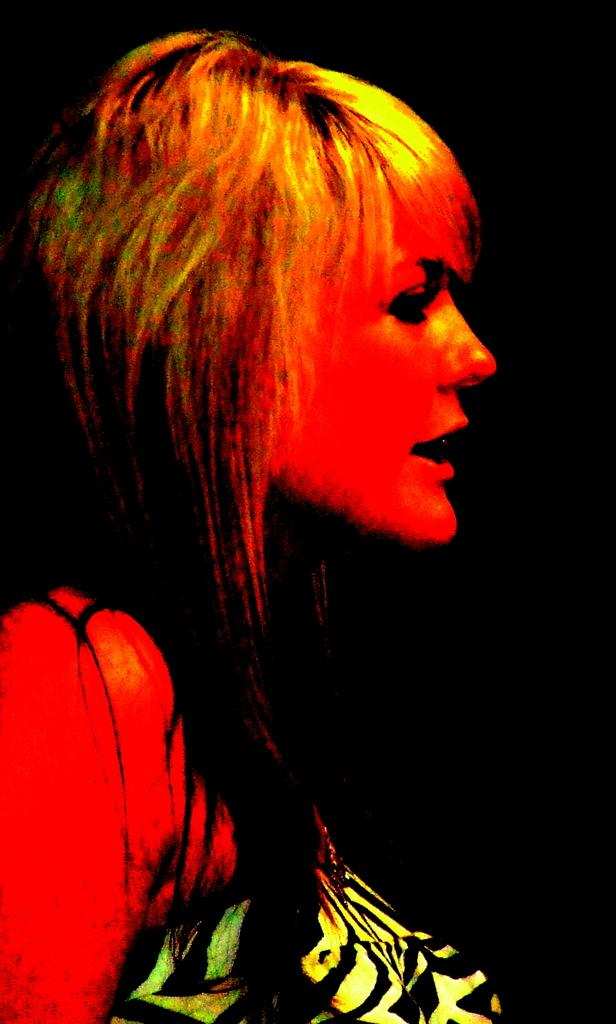Who is the main subject in the image? There is a woman in the front of the image. What can be observed about the background of the image? The background of the image is dark. What type of books are being destroyed in the image? There are no books present in the image, and therefore no destruction of books can be observed. 